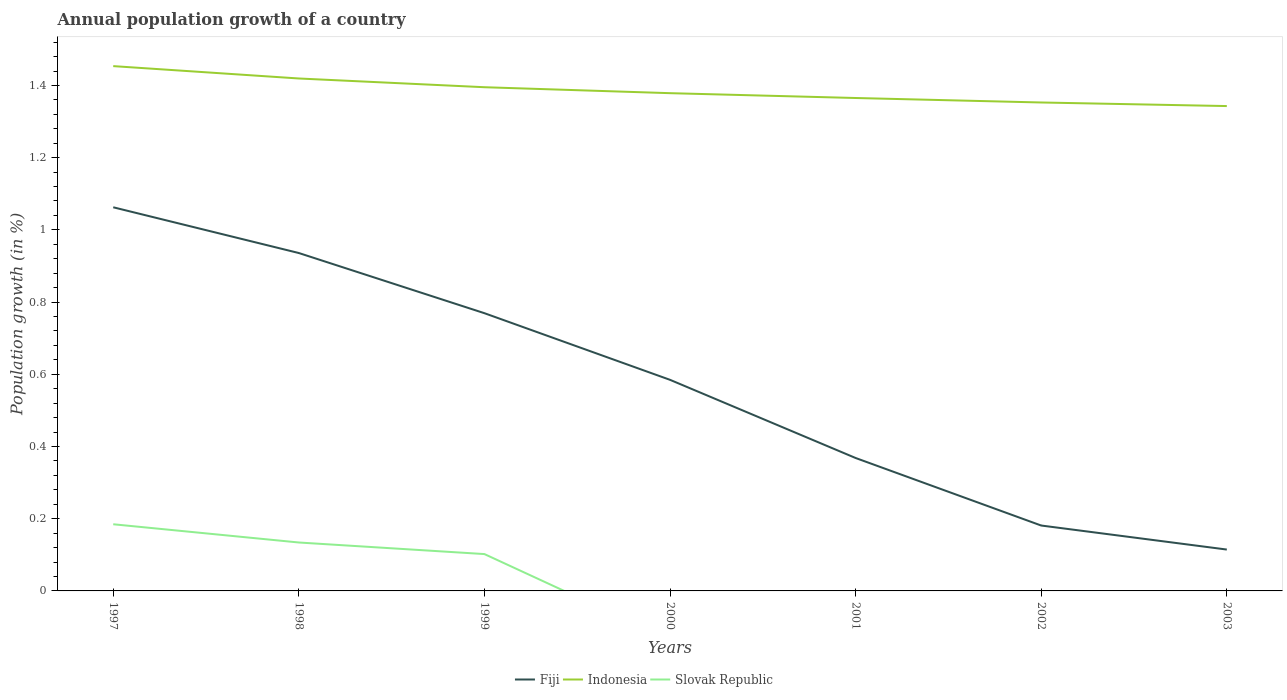Does the line corresponding to Indonesia intersect with the line corresponding to Slovak Republic?
Your answer should be very brief. No. Is the number of lines equal to the number of legend labels?
Make the answer very short. No. Across all years, what is the maximum annual population growth in Fiji?
Keep it short and to the point. 0.11. What is the total annual population growth in Indonesia in the graph?
Offer a very short reply. 0.02. What is the difference between the highest and the second highest annual population growth in Indonesia?
Your answer should be compact. 0.11. How many lines are there?
Keep it short and to the point. 3. What is the difference between two consecutive major ticks on the Y-axis?
Your response must be concise. 0.2. Does the graph contain grids?
Offer a terse response. No. Where does the legend appear in the graph?
Your answer should be very brief. Bottom center. How are the legend labels stacked?
Provide a short and direct response. Horizontal. What is the title of the graph?
Keep it short and to the point. Annual population growth of a country. What is the label or title of the X-axis?
Provide a short and direct response. Years. What is the label or title of the Y-axis?
Your answer should be compact. Population growth (in %). What is the Population growth (in %) of Fiji in 1997?
Your response must be concise. 1.06. What is the Population growth (in %) of Indonesia in 1997?
Give a very brief answer. 1.45. What is the Population growth (in %) of Slovak Republic in 1997?
Your answer should be compact. 0.18. What is the Population growth (in %) of Fiji in 1998?
Offer a terse response. 0.94. What is the Population growth (in %) of Indonesia in 1998?
Make the answer very short. 1.42. What is the Population growth (in %) of Slovak Republic in 1998?
Your answer should be compact. 0.13. What is the Population growth (in %) in Fiji in 1999?
Make the answer very short. 0.77. What is the Population growth (in %) in Indonesia in 1999?
Provide a short and direct response. 1.4. What is the Population growth (in %) of Slovak Republic in 1999?
Give a very brief answer. 0.1. What is the Population growth (in %) in Fiji in 2000?
Provide a short and direct response. 0.58. What is the Population growth (in %) in Indonesia in 2000?
Keep it short and to the point. 1.38. What is the Population growth (in %) in Slovak Republic in 2000?
Provide a succinct answer. 0. What is the Population growth (in %) of Fiji in 2001?
Your answer should be very brief. 0.37. What is the Population growth (in %) of Indonesia in 2001?
Offer a terse response. 1.37. What is the Population growth (in %) of Fiji in 2002?
Your response must be concise. 0.18. What is the Population growth (in %) of Indonesia in 2002?
Keep it short and to the point. 1.35. What is the Population growth (in %) of Slovak Republic in 2002?
Make the answer very short. 0. What is the Population growth (in %) in Fiji in 2003?
Your answer should be compact. 0.11. What is the Population growth (in %) in Indonesia in 2003?
Your answer should be very brief. 1.34. Across all years, what is the maximum Population growth (in %) of Fiji?
Give a very brief answer. 1.06. Across all years, what is the maximum Population growth (in %) in Indonesia?
Give a very brief answer. 1.45. Across all years, what is the maximum Population growth (in %) in Slovak Republic?
Offer a terse response. 0.18. Across all years, what is the minimum Population growth (in %) in Fiji?
Offer a terse response. 0.11. Across all years, what is the minimum Population growth (in %) in Indonesia?
Make the answer very short. 1.34. Across all years, what is the minimum Population growth (in %) of Slovak Republic?
Provide a short and direct response. 0. What is the total Population growth (in %) of Fiji in the graph?
Offer a terse response. 4.02. What is the total Population growth (in %) of Indonesia in the graph?
Provide a succinct answer. 9.71. What is the total Population growth (in %) of Slovak Republic in the graph?
Provide a succinct answer. 0.42. What is the difference between the Population growth (in %) of Fiji in 1997 and that in 1998?
Offer a terse response. 0.13. What is the difference between the Population growth (in %) of Indonesia in 1997 and that in 1998?
Give a very brief answer. 0.03. What is the difference between the Population growth (in %) in Slovak Republic in 1997 and that in 1998?
Offer a terse response. 0.05. What is the difference between the Population growth (in %) in Fiji in 1997 and that in 1999?
Provide a short and direct response. 0.29. What is the difference between the Population growth (in %) in Indonesia in 1997 and that in 1999?
Offer a terse response. 0.06. What is the difference between the Population growth (in %) in Slovak Republic in 1997 and that in 1999?
Your response must be concise. 0.08. What is the difference between the Population growth (in %) of Fiji in 1997 and that in 2000?
Ensure brevity in your answer.  0.48. What is the difference between the Population growth (in %) of Indonesia in 1997 and that in 2000?
Keep it short and to the point. 0.07. What is the difference between the Population growth (in %) of Fiji in 1997 and that in 2001?
Offer a terse response. 0.69. What is the difference between the Population growth (in %) of Indonesia in 1997 and that in 2001?
Your answer should be compact. 0.09. What is the difference between the Population growth (in %) in Fiji in 1997 and that in 2002?
Ensure brevity in your answer.  0.88. What is the difference between the Population growth (in %) of Indonesia in 1997 and that in 2002?
Ensure brevity in your answer.  0.1. What is the difference between the Population growth (in %) of Fiji in 1997 and that in 2003?
Your answer should be compact. 0.95. What is the difference between the Population growth (in %) of Indonesia in 1997 and that in 2003?
Give a very brief answer. 0.11. What is the difference between the Population growth (in %) of Fiji in 1998 and that in 1999?
Your response must be concise. 0.17. What is the difference between the Population growth (in %) of Indonesia in 1998 and that in 1999?
Your answer should be compact. 0.02. What is the difference between the Population growth (in %) of Slovak Republic in 1998 and that in 1999?
Keep it short and to the point. 0.03. What is the difference between the Population growth (in %) of Fiji in 1998 and that in 2000?
Make the answer very short. 0.35. What is the difference between the Population growth (in %) in Indonesia in 1998 and that in 2000?
Keep it short and to the point. 0.04. What is the difference between the Population growth (in %) in Fiji in 1998 and that in 2001?
Give a very brief answer. 0.57. What is the difference between the Population growth (in %) in Indonesia in 1998 and that in 2001?
Offer a very short reply. 0.05. What is the difference between the Population growth (in %) in Fiji in 1998 and that in 2002?
Offer a terse response. 0.75. What is the difference between the Population growth (in %) of Indonesia in 1998 and that in 2002?
Your response must be concise. 0.07. What is the difference between the Population growth (in %) in Fiji in 1998 and that in 2003?
Your answer should be compact. 0.82. What is the difference between the Population growth (in %) in Indonesia in 1998 and that in 2003?
Your answer should be compact. 0.08. What is the difference between the Population growth (in %) in Fiji in 1999 and that in 2000?
Keep it short and to the point. 0.18. What is the difference between the Population growth (in %) of Indonesia in 1999 and that in 2000?
Give a very brief answer. 0.02. What is the difference between the Population growth (in %) of Fiji in 1999 and that in 2001?
Your answer should be very brief. 0.4. What is the difference between the Population growth (in %) of Indonesia in 1999 and that in 2001?
Offer a terse response. 0.03. What is the difference between the Population growth (in %) of Fiji in 1999 and that in 2002?
Your answer should be compact. 0.59. What is the difference between the Population growth (in %) in Indonesia in 1999 and that in 2002?
Provide a succinct answer. 0.04. What is the difference between the Population growth (in %) in Fiji in 1999 and that in 2003?
Your answer should be very brief. 0.65. What is the difference between the Population growth (in %) in Indonesia in 1999 and that in 2003?
Make the answer very short. 0.05. What is the difference between the Population growth (in %) of Fiji in 2000 and that in 2001?
Give a very brief answer. 0.22. What is the difference between the Population growth (in %) in Indonesia in 2000 and that in 2001?
Ensure brevity in your answer.  0.01. What is the difference between the Population growth (in %) of Fiji in 2000 and that in 2002?
Your answer should be very brief. 0.4. What is the difference between the Population growth (in %) of Indonesia in 2000 and that in 2002?
Provide a succinct answer. 0.03. What is the difference between the Population growth (in %) of Fiji in 2000 and that in 2003?
Make the answer very short. 0.47. What is the difference between the Population growth (in %) of Indonesia in 2000 and that in 2003?
Provide a short and direct response. 0.04. What is the difference between the Population growth (in %) of Fiji in 2001 and that in 2002?
Provide a short and direct response. 0.19. What is the difference between the Population growth (in %) in Indonesia in 2001 and that in 2002?
Keep it short and to the point. 0.01. What is the difference between the Population growth (in %) of Fiji in 2001 and that in 2003?
Ensure brevity in your answer.  0.25. What is the difference between the Population growth (in %) in Indonesia in 2001 and that in 2003?
Keep it short and to the point. 0.02. What is the difference between the Population growth (in %) of Fiji in 2002 and that in 2003?
Your answer should be compact. 0.07. What is the difference between the Population growth (in %) of Indonesia in 2002 and that in 2003?
Give a very brief answer. 0.01. What is the difference between the Population growth (in %) in Fiji in 1997 and the Population growth (in %) in Indonesia in 1998?
Make the answer very short. -0.36. What is the difference between the Population growth (in %) of Fiji in 1997 and the Population growth (in %) of Slovak Republic in 1998?
Your answer should be very brief. 0.93. What is the difference between the Population growth (in %) of Indonesia in 1997 and the Population growth (in %) of Slovak Republic in 1998?
Make the answer very short. 1.32. What is the difference between the Population growth (in %) of Fiji in 1997 and the Population growth (in %) of Indonesia in 1999?
Provide a short and direct response. -0.33. What is the difference between the Population growth (in %) of Fiji in 1997 and the Population growth (in %) of Slovak Republic in 1999?
Keep it short and to the point. 0.96. What is the difference between the Population growth (in %) in Indonesia in 1997 and the Population growth (in %) in Slovak Republic in 1999?
Keep it short and to the point. 1.35. What is the difference between the Population growth (in %) of Fiji in 1997 and the Population growth (in %) of Indonesia in 2000?
Keep it short and to the point. -0.32. What is the difference between the Population growth (in %) in Fiji in 1997 and the Population growth (in %) in Indonesia in 2001?
Your answer should be very brief. -0.3. What is the difference between the Population growth (in %) in Fiji in 1997 and the Population growth (in %) in Indonesia in 2002?
Make the answer very short. -0.29. What is the difference between the Population growth (in %) in Fiji in 1997 and the Population growth (in %) in Indonesia in 2003?
Your answer should be compact. -0.28. What is the difference between the Population growth (in %) in Fiji in 1998 and the Population growth (in %) in Indonesia in 1999?
Your answer should be compact. -0.46. What is the difference between the Population growth (in %) of Fiji in 1998 and the Population growth (in %) of Slovak Republic in 1999?
Your answer should be very brief. 0.83. What is the difference between the Population growth (in %) in Indonesia in 1998 and the Population growth (in %) in Slovak Republic in 1999?
Your answer should be compact. 1.32. What is the difference between the Population growth (in %) in Fiji in 1998 and the Population growth (in %) in Indonesia in 2000?
Offer a terse response. -0.44. What is the difference between the Population growth (in %) in Fiji in 1998 and the Population growth (in %) in Indonesia in 2001?
Provide a succinct answer. -0.43. What is the difference between the Population growth (in %) in Fiji in 1998 and the Population growth (in %) in Indonesia in 2002?
Make the answer very short. -0.42. What is the difference between the Population growth (in %) of Fiji in 1998 and the Population growth (in %) of Indonesia in 2003?
Make the answer very short. -0.41. What is the difference between the Population growth (in %) of Fiji in 1999 and the Population growth (in %) of Indonesia in 2000?
Your response must be concise. -0.61. What is the difference between the Population growth (in %) of Fiji in 1999 and the Population growth (in %) of Indonesia in 2001?
Make the answer very short. -0.6. What is the difference between the Population growth (in %) of Fiji in 1999 and the Population growth (in %) of Indonesia in 2002?
Your answer should be very brief. -0.58. What is the difference between the Population growth (in %) of Fiji in 1999 and the Population growth (in %) of Indonesia in 2003?
Your answer should be very brief. -0.57. What is the difference between the Population growth (in %) of Fiji in 2000 and the Population growth (in %) of Indonesia in 2001?
Ensure brevity in your answer.  -0.78. What is the difference between the Population growth (in %) of Fiji in 2000 and the Population growth (in %) of Indonesia in 2002?
Provide a succinct answer. -0.77. What is the difference between the Population growth (in %) in Fiji in 2000 and the Population growth (in %) in Indonesia in 2003?
Your answer should be very brief. -0.76. What is the difference between the Population growth (in %) of Fiji in 2001 and the Population growth (in %) of Indonesia in 2002?
Offer a terse response. -0.98. What is the difference between the Population growth (in %) in Fiji in 2001 and the Population growth (in %) in Indonesia in 2003?
Ensure brevity in your answer.  -0.97. What is the difference between the Population growth (in %) of Fiji in 2002 and the Population growth (in %) of Indonesia in 2003?
Give a very brief answer. -1.16. What is the average Population growth (in %) of Fiji per year?
Keep it short and to the point. 0.57. What is the average Population growth (in %) in Indonesia per year?
Your answer should be very brief. 1.39. What is the average Population growth (in %) in Slovak Republic per year?
Give a very brief answer. 0.06. In the year 1997, what is the difference between the Population growth (in %) in Fiji and Population growth (in %) in Indonesia?
Provide a succinct answer. -0.39. In the year 1997, what is the difference between the Population growth (in %) of Fiji and Population growth (in %) of Slovak Republic?
Your answer should be very brief. 0.88. In the year 1997, what is the difference between the Population growth (in %) of Indonesia and Population growth (in %) of Slovak Republic?
Offer a terse response. 1.27. In the year 1998, what is the difference between the Population growth (in %) of Fiji and Population growth (in %) of Indonesia?
Your response must be concise. -0.48. In the year 1998, what is the difference between the Population growth (in %) of Fiji and Population growth (in %) of Slovak Republic?
Your answer should be compact. 0.8. In the year 1998, what is the difference between the Population growth (in %) of Indonesia and Population growth (in %) of Slovak Republic?
Offer a very short reply. 1.29. In the year 1999, what is the difference between the Population growth (in %) in Fiji and Population growth (in %) in Indonesia?
Ensure brevity in your answer.  -0.63. In the year 1999, what is the difference between the Population growth (in %) of Fiji and Population growth (in %) of Slovak Republic?
Provide a succinct answer. 0.67. In the year 1999, what is the difference between the Population growth (in %) of Indonesia and Population growth (in %) of Slovak Republic?
Make the answer very short. 1.29. In the year 2000, what is the difference between the Population growth (in %) of Fiji and Population growth (in %) of Indonesia?
Your answer should be very brief. -0.79. In the year 2001, what is the difference between the Population growth (in %) of Fiji and Population growth (in %) of Indonesia?
Your response must be concise. -1. In the year 2002, what is the difference between the Population growth (in %) of Fiji and Population growth (in %) of Indonesia?
Give a very brief answer. -1.17. In the year 2003, what is the difference between the Population growth (in %) of Fiji and Population growth (in %) of Indonesia?
Ensure brevity in your answer.  -1.23. What is the ratio of the Population growth (in %) in Fiji in 1997 to that in 1998?
Provide a short and direct response. 1.14. What is the ratio of the Population growth (in %) of Indonesia in 1997 to that in 1998?
Provide a succinct answer. 1.02. What is the ratio of the Population growth (in %) in Slovak Republic in 1997 to that in 1998?
Keep it short and to the point. 1.38. What is the ratio of the Population growth (in %) in Fiji in 1997 to that in 1999?
Your response must be concise. 1.38. What is the ratio of the Population growth (in %) of Indonesia in 1997 to that in 1999?
Provide a succinct answer. 1.04. What is the ratio of the Population growth (in %) of Slovak Republic in 1997 to that in 1999?
Your answer should be compact. 1.81. What is the ratio of the Population growth (in %) in Fiji in 1997 to that in 2000?
Make the answer very short. 1.82. What is the ratio of the Population growth (in %) of Indonesia in 1997 to that in 2000?
Your answer should be compact. 1.05. What is the ratio of the Population growth (in %) of Fiji in 1997 to that in 2001?
Ensure brevity in your answer.  2.89. What is the ratio of the Population growth (in %) in Indonesia in 1997 to that in 2001?
Provide a short and direct response. 1.06. What is the ratio of the Population growth (in %) of Fiji in 1997 to that in 2002?
Make the answer very short. 5.87. What is the ratio of the Population growth (in %) in Indonesia in 1997 to that in 2002?
Ensure brevity in your answer.  1.07. What is the ratio of the Population growth (in %) of Fiji in 1997 to that in 2003?
Offer a terse response. 9.28. What is the ratio of the Population growth (in %) of Indonesia in 1997 to that in 2003?
Provide a succinct answer. 1.08. What is the ratio of the Population growth (in %) of Fiji in 1998 to that in 1999?
Provide a succinct answer. 1.22. What is the ratio of the Population growth (in %) of Indonesia in 1998 to that in 1999?
Ensure brevity in your answer.  1.02. What is the ratio of the Population growth (in %) of Slovak Republic in 1998 to that in 1999?
Your answer should be compact. 1.31. What is the ratio of the Population growth (in %) in Fiji in 1998 to that in 2000?
Provide a short and direct response. 1.6. What is the ratio of the Population growth (in %) in Indonesia in 1998 to that in 2000?
Provide a short and direct response. 1.03. What is the ratio of the Population growth (in %) in Fiji in 1998 to that in 2001?
Your response must be concise. 2.54. What is the ratio of the Population growth (in %) of Indonesia in 1998 to that in 2001?
Make the answer very short. 1.04. What is the ratio of the Population growth (in %) of Fiji in 1998 to that in 2002?
Your answer should be compact. 5.17. What is the ratio of the Population growth (in %) of Indonesia in 1998 to that in 2002?
Keep it short and to the point. 1.05. What is the ratio of the Population growth (in %) in Fiji in 1998 to that in 2003?
Provide a succinct answer. 8.17. What is the ratio of the Population growth (in %) in Indonesia in 1998 to that in 2003?
Provide a short and direct response. 1.06. What is the ratio of the Population growth (in %) in Fiji in 1999 to that in 2000?
Your answer should be very brief. 1.32. What is the ratio of the Population growth (in %) of Indonesia in 1999 to that in 2000?
Ensure brevity in your answer.  1.01. What is the ratio of the Population growth (in %) of Fiji in 1999 to that in 2001?
Your answer should be very brief. 2.09. What is the ratio of the Population growth (in %) of Indonesia in 1999 to that in 2001?
Make the answer very short. 1.02. What is the ratio of the Population growth (in %) in Fiji in 1999 to that in 2002?
Your answer should be compact. 4.25. What is the ratio of the Population growth (in %) of Indonesia in 1999 to that in 2002?
Give a very brief answer. 1.03. What is the ratio of the Population growth (in %) of Fiji in 1999 to that in 2003?
Give a very brief answer. 6.71. What is the ratio of the Population growth (in %) in Indonesia in 1999 to that in 2003?
Give a very brief answer. 1.04. What is the ratio of the Population growth (in %) in Fiji in 2000 to that in 2001?
Your answer should be very brief. 1.59. What is the ratio of the Population growth (in %) of Indonesia in 2000 to that in 2001?
Give a very brief answer. 1.01. What is the ratio of the Population growth (in %) in Fiji in 2000 to that in 2002?
Your answer should be very brief. 3.23. What is the ratio of the Population growth (in %) of Indonesia in 2000 to that in 2002?
Ensure brevity in your answer.  1.02. What is the ratio of the Population growth (in %) of Fiji in 2000 to that in 2003?
Ensure brevity in your answer.  5.1. What is the ratio of the Population growth (in %) in Indonesia in 2000 to that in 2003?
Provide a succinct answer. 1.03. What is the ratio of the Population growth (in %) in Fiji in 2001 to that in 2002?
Your response must be concise. 2.03. What is the ratio of the Population growth (in %) in Indonesia in 2001 to that in 2002?
Ensure brevity in your answer.  1.01. What is the ratio of the Population growth (in %) in Fiji in 2001 to that in 2003?
Ensure brevity in your answer.  3.21. What is the ratio of the Population growth (in %) of Indonesia in 2001 to that in 2003?
Make the answer very short. 1.02. What is the ratio of the Population growth (in %) in Fiji in 2002 to that in 2003?
Provide a succinct answer. 1.58. What is the ratio of the Population growth (in %) in Indonesia in 2002 to that in 2003?
Offer a terse response. 1.01. What is the difference between the highest and the second highest Population growth (in %) of Fiji?
Make the answer very short. 0.13. What is the difference between the highest and the second highest Population growth (in %) in Indonesia?
Ensure brevity in your answer.  0.03. What is the difference between the highest and the second highest Population growth (in %) of Slovak Republic?
Offer a very short reply. 0.05. What is the difference between the highest and the lowest Population growth (in %) in Fiji?
Give a very brief answer. 0.95. What is the difference between the highest and the lowest Population growth (in %) of Indonesia?
Offer a terse response. 0.11. What is the difference between the highest and the lowest Population growth (in %) in Slovak Republic?
Keep it short and to the point. 0.18. 